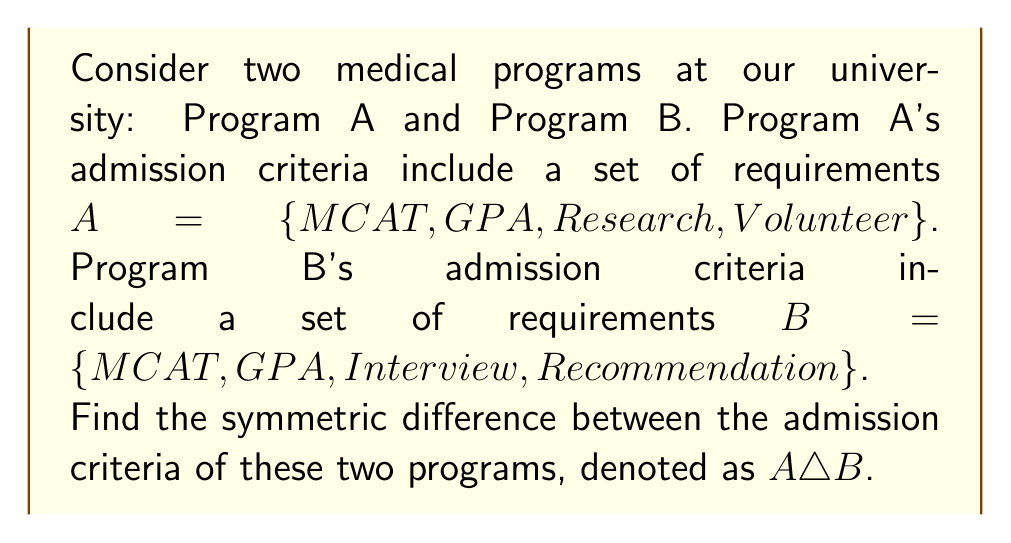What is the answer to this math problem? To solve this problem, we need to understand the concept of symmetric difference in set theory:

1) The symmetric difference of two sets A and B, denoted as $A \triangle B$, is the set of elements that are in either A or B, but not in both.

2) Mathematically, this can be expressed as:
   $A \triangle B = (A \setminus B) \cup (B \setminus A)$
   where $\setminus$ denotes set difference.

3) Let's identify the elements in each set:
   $A = \{MCAT, GPA, Research, Volunteer\}$
   $B = \{MCAT, GPA, Interview, Recommendation\}$

4) Now, let's find $A \setminus B$ (elements in A but not in B):
   $A \setminus B = \{Research, Volunteer\}$

5) Next, let's find $B \setminus A$ (elements in B but not in A):
   $B \setminus A = \{Interview, Recommendation\}$

6) The symmetric difference is the union of these two sets:
   $A \triangle B = (A \setminus B) \cup (B \setminus A)$
                 $= \{Research, Volunteer\} \cup \{Interview, Recommendation\}$
                 $= \{Research, Volunteer, Interview, Recommendation\}$

Therefore, the symmetric difference represents the unique admission criteria for each program.
Answer: $A \triangle B = \{Research, Volunteer, Interview, Recommendation\}$ 